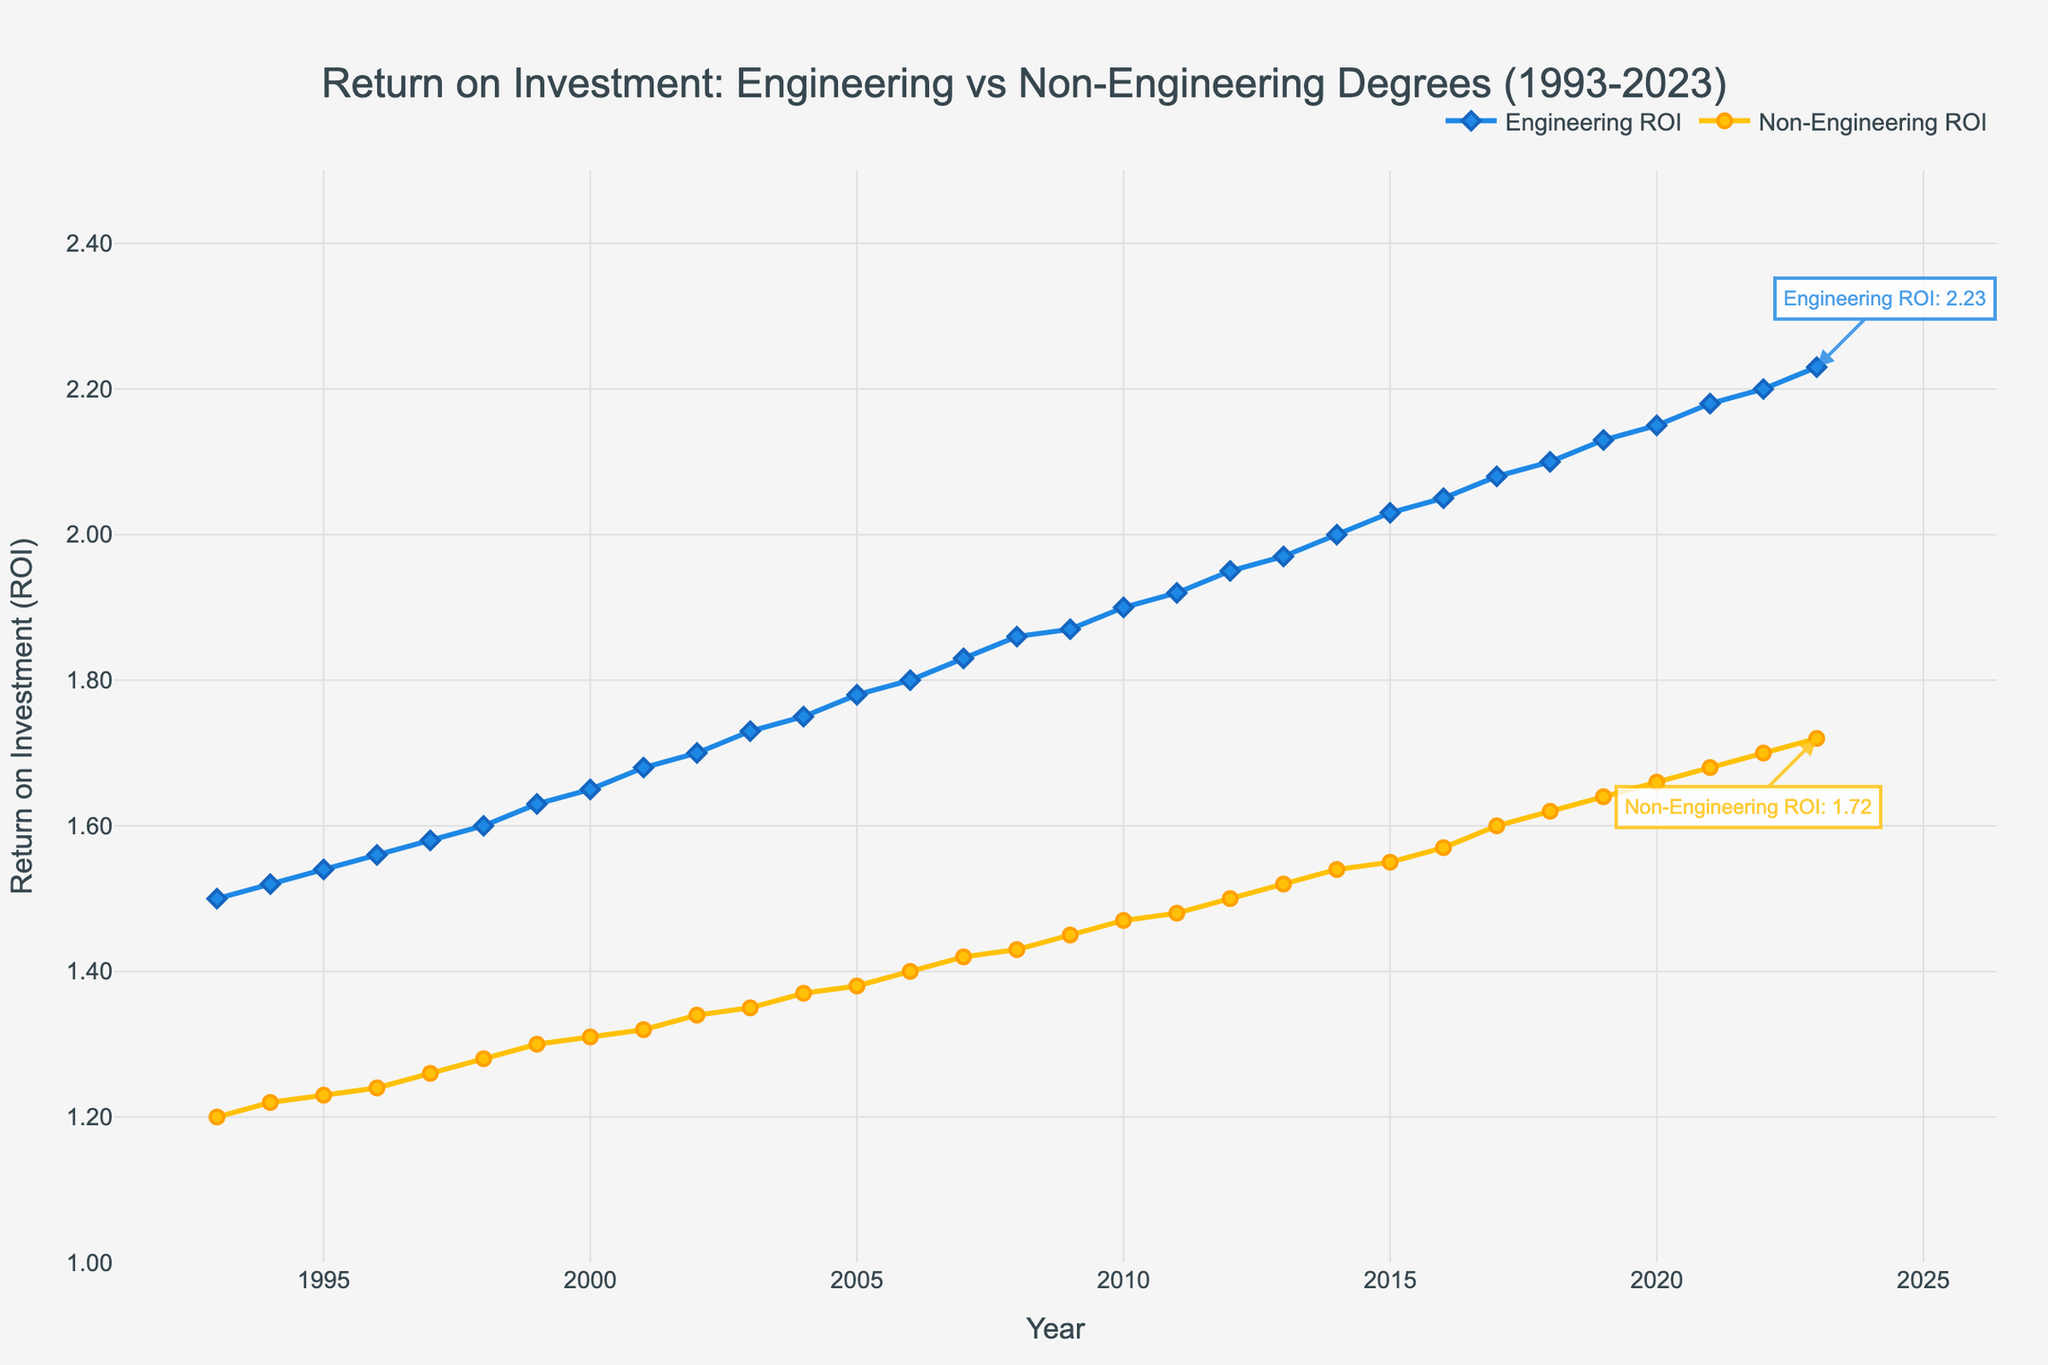What's the title of the plot? The title of the plot is displayed at the top center of the figure. It reads: "Return on Investment: Engineering vs Non-Engineering Degrees (1993-2023)."
Answer: Return on Investment: Engineering vs Non-Engineering Degrees (1993-2023) What is the ROI for Engineering degrees in 2023? Look at the annotation on the figure marking the ROI for Engineering degrees at the year 2023. The annotation shows the value and an arrow points to the data point.
Answer: 2.23 How does the ROI for Non-Engineering degrees in 2023 compare to that for Engineering degrees in the same year? Find both annotated values for 2023 and compare them. Engineering ROI in 2023 is 2.23, while Non-Engineering ROI is 1.72.
Answer: Engineering ROI is higher What is the approximate difference in ROI between Engineering and Non-Engineering degrees in 2001? Locate the data points for both Engineering and Non-Engineering ROIs for the year 2001. Engineering ROI is 1.68 and Non-Engineering ROI is 1.32. Subtract Non-Engineering ROI from Engineering ROI: 1.68 - 1.32.
Answer: 0.36 How has the ROI for Engineering degrees changed from 1993 to 2023? Examine the trend of the Engineering ROI line from 1993 to 2023. Note the increase in value from 1.5 in 1993 to 2.23 in 2023.
Answer: It has increased Between which years did Non-Engineering degrees experience the most significant increase in ROI? Look at the Non-Engineering ROI line and identify the period with the steepest upward slope, which appears to be from around 2015 to 2023.
Answer: 2015 to 2023 How does the trend in ROI for Non-Engineering degrees compare to that for Engineering degrees over 30 years? Compare the two lines. Both have increased, but the Engineering ROI has a steeper and more consistent upward trend compared to the Non-Engineering ROI.
Answer: Engineering ROI increased more consistently and rapidly What is the average ROI for Engineering degrees over the first 10 years (1993-2002)? Identify and sum the ROI values for Engineering degrees from 1993 to 2002: 1.5, 1.52, 1.54, 1.56, 1.58, 1.60, 1.63, 1.65, 1.68, 1.70. Divide by 10 to find the average. (1.5 + 1.52 + 1.54 + 1.56 + 1.58 + 1.60 + 1.63 + 1.65 + 1.68 + 1.70) / 10 = 15.96 / 10.
Answer: 1.60 What annotation is used to highlight the ROI values for 2023? Notice the two annotations: “Engineering ROI: 2.23” in blue and “Non-Engineering ROI: 1.72” in yellow, each with arrows pointing to their respective data points.
Answer: Values and arrows By how much did the ROI for Non-Engineering degrees increase from 1999 to 2008? Identify the ROI values for Non-Engineering degrees in 1999 (1.30) and 2008 (1.43). Subtract the 1999 value from the 2008 value to find the increase: 1.43 - 1.30.
Answer: 0.13 